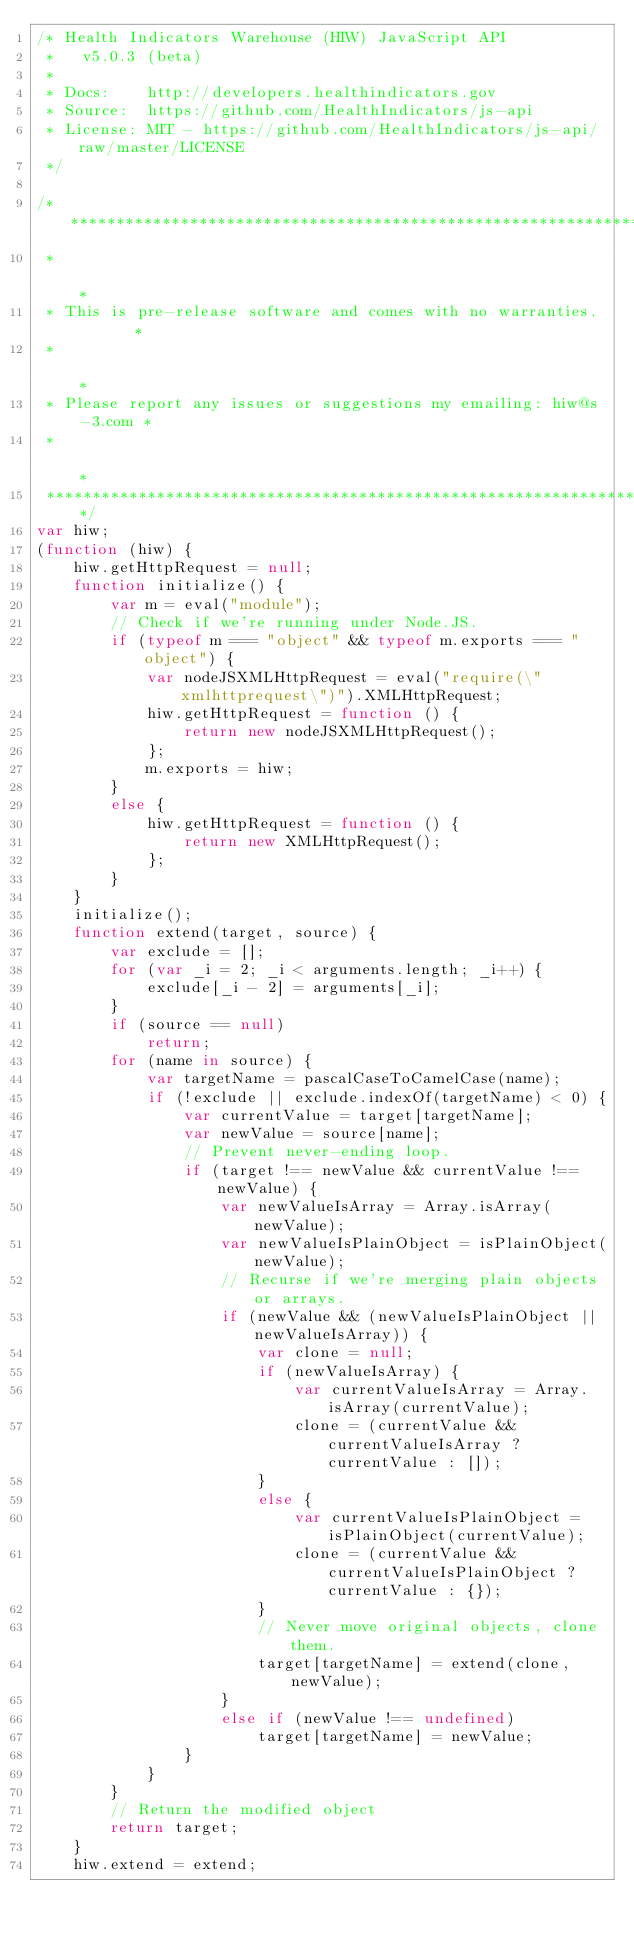Convert code to text. <code><loc_0><loc_0><loc_500><loc_500><_JavaScript_>/* Health Indicators Warehouse (HIW) JavaScript API
 *   v5.0.3 (beta)
 * 
 * Docs:    http://developers.healthindicators.gov
 * Source:  https://github.com/HealthIndicators/js-api
 * License: MIT - https://github.com/HealthIndicators/js-api/raw/master/LICENSE
 */

/********************************************************************
 *                                                                  *
 * This is pre-release software and comes with no warranties.       *
 *                                                                  *
 * Please report any issues or suggestions my emailing: hiw@s-3.com *
 *                                                                  *
 ********************************************************************/
var hiw;
(function (hiw) {
    hiw.getHttpRequest = null;
    function initialize() {
        var m = eval("module");
        // Check if we're running under Node.JS.
        if (typeof m === "object" && typeof m.exports === "object") {
            var nodeJSXMLHttpRequest = eval("require(\"xmlhttprequest\")").XMLHttpRequest;
            hiw.getHttpRequest = function () {
                return new nodeJSXMLHttpRequest();
            };
            m.exports = hiw;
        }
        else {
            hiw.getHttpRequest = function () {
                return new XMLHttpRequest();
            };
        }
    }
    initialize();
    function extend(target, source) {
        var exclude = [];
        for (var _i = 2; _i < arguments.length; _i++) {
            exclude[_i - 2] = arguments[_i];
        }
        if (source == null)
            return;
        for (name in source) {
            var targetName = pascalCaseToCamelCase(name);
            if (!exclude || exclude.indexOf(targetName) < 0) {
                var currentValue = target[targetName];
                var newValue = source[name];
                // Prevent never-ending loop.
                if (target !== newValue && currentValue !== newValue) {
                    var newValueIsArray = Array.isArray(newValue);
                    var newValueIsPlainObject = isPlainObject(newValue);
                    // Recurse if we're merging plain objects or arrays.
                    if (newValue && (newValueIsPlainObject || newValueIsArray)) {
                        var clone = null;
                        if (newValueIsArray) {
                            var currentValueIsArray = Array.isArray(currentValue);
                            clone = (currentValue && currentValueIsArray ? currentValue : []);
                        }
                        else {
                            var currentValueIsPlainObject = isPlainObject(currentValue);
                            clone = (currentValue && currentValueIsPlainObject ? currentValue : {});
                        }
                        // Never move original objects, clone them.
                        target[targetName] = extend(clone, newValue);
                    }
                    else if (newValue !== undefined)
                        target[targetName] = newValue;
                }
            }
        }
        // Return the modified object
        return target;
    }
    hiw.extend = extend;</code> 